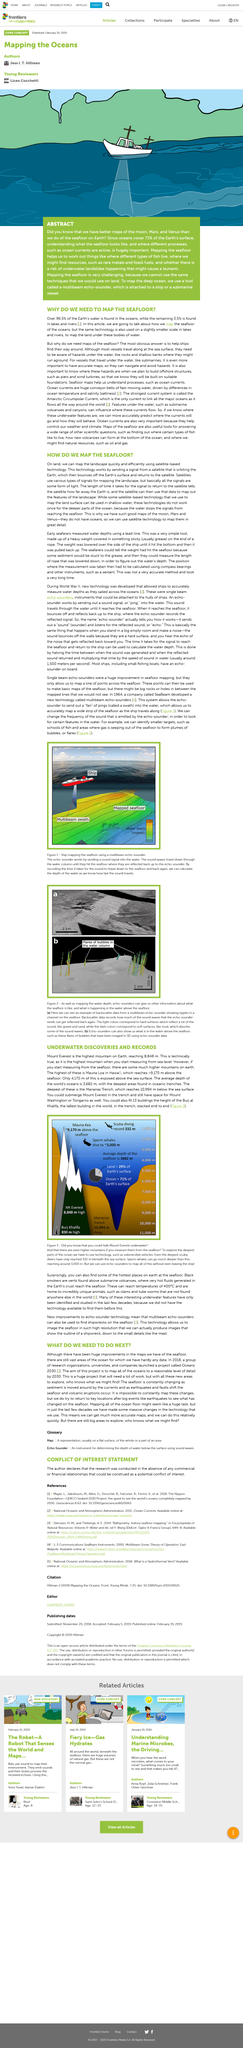Give some essential details in this illustration. The creation of maps of the seafloor is essential for enabling ships to navigate and safely traverse the ocean. Mount Everest, the highest mountain on Earth, reaches a height of 8,848 meters. The average depth of the world's oceans is 3,682 meters. The seafloor can reach temperatures of up to 400 degrees Celsius, which is the maximum temperature that can be reached at that depth. During World War II, new technology was developed that allowed ships to accurately measure water depths as they sailed across the oceans. This technology played a crucial role in the war effort and laid the foundation for modern navigation systems. 